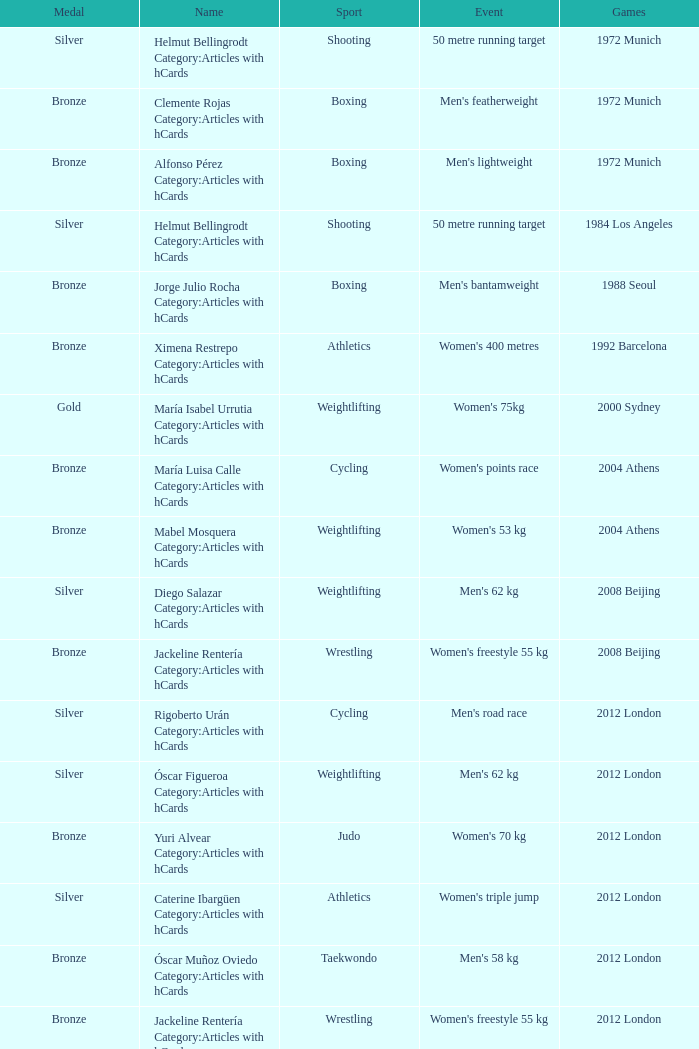What wrestling event was participated in during the 2008 Beijing games? Women's freestyle 55 kg. 